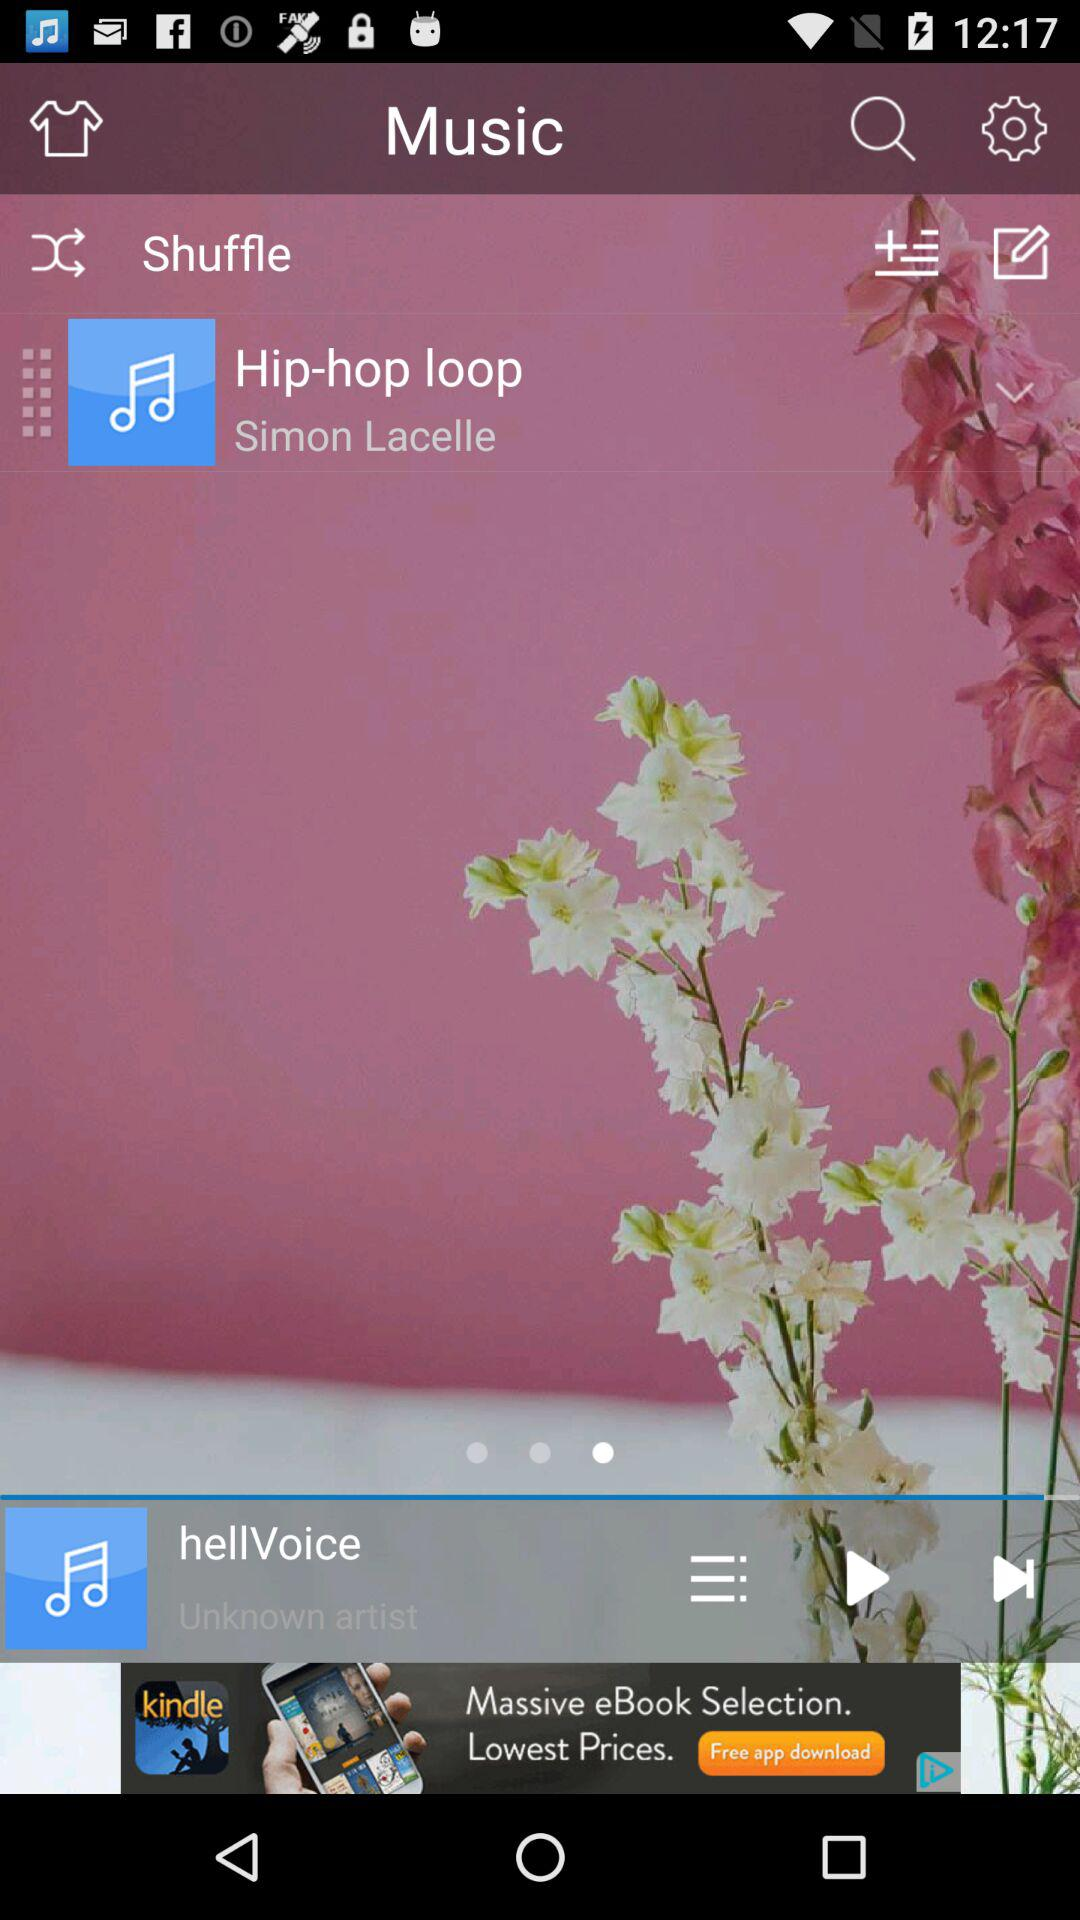Which song was last played? The last played song was "hellVoice". 